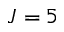<formula> <loc_0><loc_0><loc_500><loc_500>J = 5</formula> 